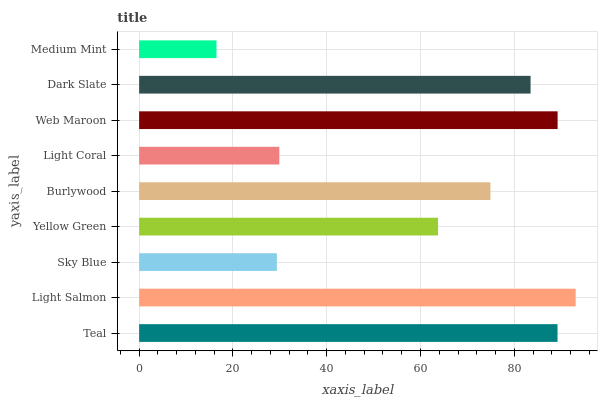Is Medium Mint the minimum?
Answer yes or no. Yes. Is Light Salmon the maximum?
Answer yes or no. Yes. Is Sky Blue the minimum?
Answer yes or no. No. Is Sky Blue the maximum?
Answer yes or no. No. Is Light Salmon greater than Sky Blue?
Answer yes or no. Yes. Is Sky Blue less than Light Salmon?
Answer yes or no. Yes. Is Sky Blue greater than Light Salmon?
Answer yes or no. No. Is Light Salmon less than Sky Blue?
Answer yes or no. No. Is Burlywood the high median?
Answer yes or no. Yes. Is Burlywood the low median?
Answer yes or no. Yes. Is Web Maroon the high median?
Answer yes or no. No. Is Sky Blue the low median?
Answer yes or no. No. 